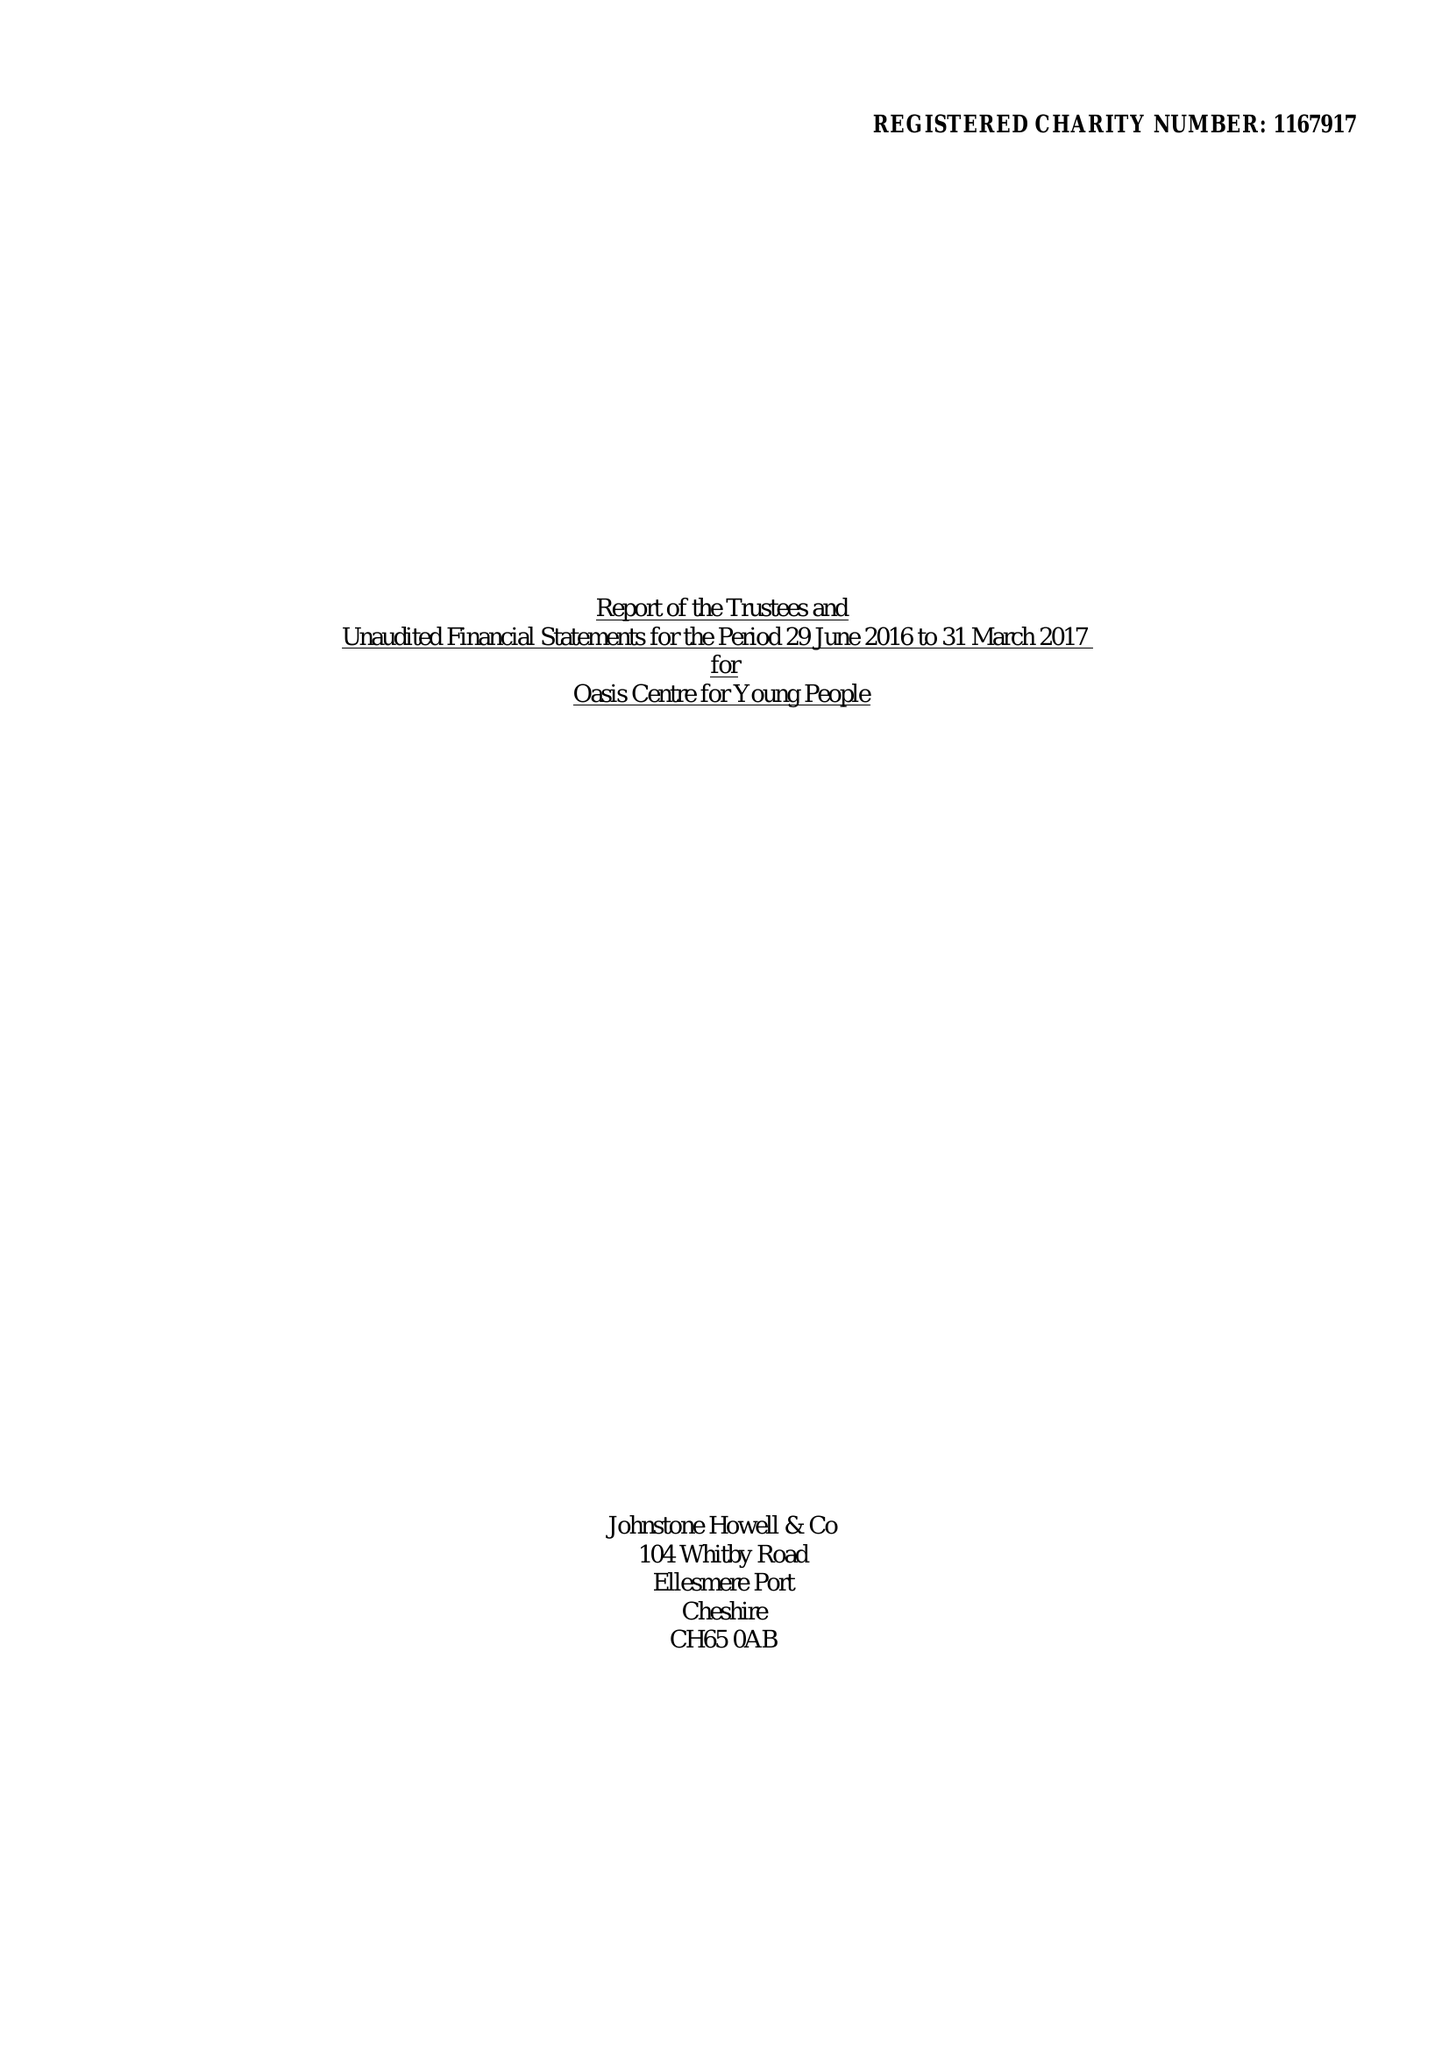What is the value for the address__postcode?
Answer the question using a single word or phrase. CH66 3NS 